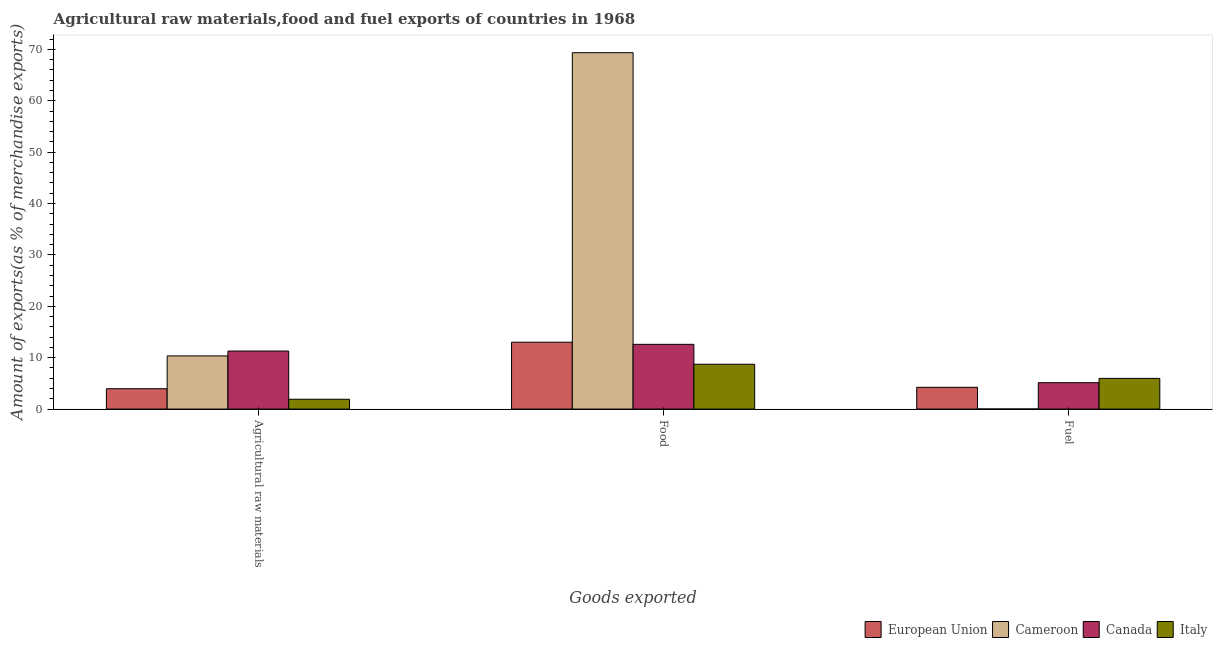How many different coloured bars are there?
Make the answer very short. 4. Are the number of bars per tick equal to the number of legend labels?
Give a very brief answer. Yes. Are the number of bars on each tick of the X-axis equal?
Ensure brevity in your answer.  Yes. How many bars are there on the 2nd tick from the left?
Offer a terse response. 4. How many bars are there on the 1st tick from the right?
Provide a succinct answer. 4. What is the label of the 2nd group of bars from the left?
Ensure brevity in your answer.  Food. What is the percentage of raw materials exports in Canada?
Provide a short and direct response. 11.29. Across all countries, what is the maximum percentage of food exports?
Provide a succinct answer. 69.35. Across all countries, what is the minimum percentage of fuel exports?
Keep it short and to the point. 0.01. In which country was the percentage of fuel exports minimum?
Offer a terse response. Cameroon. What is the total percentage of food exports in the graph?
Your answer should be very brief. 103.68. What is the difference between the percentage of raw materials exports in Canada and that in Cameroon?
Give a very brief answer. 0.95. What is the difference between the percentage of fuel exports in Canada and the percentage of raw materials exports in Italy?
Give a very brief answer. 3.22. What is the average percentage of fuel exports per country?
Your response must be concise. 3.84. What is the difference between the percentage of food exports and percentage of fuel exports in Canada?
Provide a succinct answer. 7.46. What is the ratio of the percentage of fuel exports in Italy to that in European Union?
Give a very brief answer. 1.41. Is the difference between the percentage of food exports in Canada and European Union greater than the difference between the percentage of fuel exports in Canada and European Union?
Keep it short and to the point. No. What is the difference between the highest and the second highest percentage of food exports?
Offer a very short reply. 56.34. What is the difference between the highest and the lowest percentage of fuel exports?
Offer a very short reply. 5.96. Is the sum of the percentage of food exports in Canada and Cameroon greater than the maximum percentage of fuel exports across all countries?
Provide a succinct answer. Yes. What does the 3rd bar from the left in Fuel represents?
Your answer should be very brief. Canada. Are the values on the major ticks of Y-axis written in scientific E-notation?
Provide a short and direct response. No. How many legend labels are there?
Make the answer very short. 4. What is the title of the graph?
Give a very brief answer. Agricultural raw materials,food and fuel exports of countries in 1968. What is the label or title of the X-axis?
Provide a succinct answer. Goods exported. What is the label or title of the Y-axis?
Keep it short and to the point. Amount of exports(as % of merchandise exports). What is the Amount of exports(as % of merchandise exports) in European Union in Agricultural raw materials?
Make the answer very short. 3.96. What is the Amount of exports(as % of merchandise exports) of Cameroon in Agricultural raw materials?
Offer a very short reply. 10.34. What is the Amount of exports(as % of merchandise exports) in Canada in Agricultural raw materials?
Keep it short and to the point. 11.29. What is the Amount of exports(as % of merchandise exports) in Italy in Agricultural raw materials?
Provide a short and direct response. 1.91. What is the Amount of exports(as % of merchandise exports) of European Union in Food?
Your response must be concise. 13.01. What is the Amount of exports(as % of merchandise exports) of Cameroon in Food?
Give a very brief answer. 69.35. What is the Amount of exports(as % of merchandise exports) of Canada in Food?
Make the answer very short. 12.6. What is the Amount of exports(as % of merchandise exports) of Italy in Food?
Keep it short and to the point. 8.72. What is the Amount of exports(as % of merchandise exports) of European Union in Fuel?
Ensure brevity in your answer.  4.24. What is the Amount of exports(as % of merchandise exports) in Cameroon in Fuel?
Ensure brevity in your answer.  0.01. What is the Amount of exports(as % of merchandise exports) in Canada in Fuel?
Ensure brevity in your answer.  5.13. What is the Amount of exports(as % of merchandise exports) of Italy in Fuel?
Provide a short and direct response. 5.97. Across all Goods exported, what is the maximum Amount of exports(as % of merchandise exports) in European Union?
Make the answer very short. 13.01. Across all Goods exported, what is the maximum Amount of exports(as % of merchandise exports) of Cameroon?
Keep it short and to the point. 69.35. Across all Goods exported, what is the maximum Amount of exports(as % of merchandise exports) of Canada?
Ensure brevity in your answer.  12.6. Across all Goods exported, what is the maximum Amount of exports(as % of merchandise exports) of Italy?
Ensure brevity in your answer.  8.72. Across all Goods exported, what is the minimum Amount of exports(as % of merchandise exports) of European Union?
Keep it short and to the point. 3.96. Across all Goods exported, what is the minimum Amount of exports(as % of merchandise exports) in Cameroon?
Offer a terse response. 0.01. Across all Goods exported, what is the minimum Amount of exports(as % of merchandise exports) of Canada?
Offer a very short reply. 5.13. Across all Goods exported, what is the minimum Amount of exports(as % of merchandise exports) in Italy?
Make the answer very short. 1.91. What is the total Amount of exports(as % of merchandise exports) in European Union in the graph?
Give a very brief answer. 21.21. What is the total Amount of exports(as % of merchandise exports) in Cameroon in the graph?
Provide a short and direct response. 79.71. What is the total Amount of exports(as % of merchandise exports) in Canada in the graph?
Offer a terse response. 29.03. What is the total Amount of exports(as % of merchandise exports) in Italy in the graph?
Your answer should be very brief. 16.61. What is the difference between the Amount of exports(as % of merchandise exports) in European Union in Agricultural raw materials and that in Food?
Give a very brief answer. -9.05. What is the difference between the Amount of exports(as % of merchandise exports) of Cameroon in Agricultural raw materials and that in Food?
Offer a terse response. -59.01. What is the difference between the Amount of exports(as % of merchandise exports) of Canada in Agricultural raw materials and that in Food?
Your answer should be compact. -1.31. What is the difference between the Amount of exports(as % of merchandise exports) in Italy in Agricultural raw materials and that in Food?
Keep it short and to the point. -6.81. What is the difference between the Amount of exports(as % of merchandise exports) in European Union in Agricultural raw materials and that in Fuel?
Your response must be concise. -0.28. What is the difference between the Amount of exports(as % of merchandise exports) in Cameroon in Agricultural raw materials and that in Fuel?
Give a very brief answer. 10.33. What is the difference between the Amount of exports(as % of merchandise exports) of Canada in Agricultural raw materials and that in Fuel?
Offer a very short reply. 6.16. What is the difference between the Amount of exports(as % of merchandise exports) of Italy in Agricultural raw materials and that in Fuel?
Offer a very short reply. -4.06. What is the difference between the Amount of exports(as % of merchandise exports) in European Union in Food and that in Fuel?
Keep it short and to the point. 8.77. What is the difference between the Amount of exports(as % of merchandise exports) in Cameroon in Food and that in Fuel?
Your answer should be very brief. 69.34. What is the difference between the Amount of exports(as % of merchandise exports) of Canada in Food and that in Fuel?
Give a very brief answer. 7.46. What is the difference between the Amount of exports(as % of merchandise exports) in Italy in Food and that in Fuel?
Offer a terse response. 2.75. What is the difference between the Amount of exports(as % of merchandise exports) of European Union in Agricultural raw materials and the Amount of exports(as % of merchandise exports) of Cameroon in Food?
Make the answer very short. -65.39. What is the difference between the Amount of exports(as % of merchandise exports) in European Union in Agricultural raw materials and the Amount of exports(as % of merchandise exports) in Canada in Food?
Provide a short and direct response. -8.64. What is the difference between the Amount of exports(as % of merchandise exports) in European Union in Agricultural raw materials and the Amount of exports(as % of merchandise exports) in Italy in Food?
Keep it short and to the point. -4.76. What is the difference between the Amount of exports(as % of merchandise exports) in Cameroon in Agricultural raw materials and the Amount of exports(as % of merchandise exports) in Canada in Food?
Your answer should be compact. -2.25. What is the difference between the Amount of exports(as % of merchandise exports) in Cameroon in Agricultural raw materials and the Amount of exports(as % of merchandise exports) in Italy in Food?
Make the answer very short. 1.62. What is the difference between the Amount of exports(as % of merchandise exports) in Canada in Agricultural raw materials and the Amount of exports(as % of merchandise exports) in Italy in Food?
Offer a very short reply. 2.57. What is the difference between the Amount of exports(as % of merchandise exports) in European Union in Agricultural raw materials and the Amount of exports(as % of merchandise exports) in Cameroon in Fuel?
Offer a very short reply. 3.95. What is the difference between the Amount of exports(as % of merchandise exports) in European Union in Agricultural raw materials and the Amount of exports(as % of merchandise exports) in Canada in Fuel?
Keep it short and to the point. -1.17. What is the difference between the Amount of exports(as % of merchandise exports) in European Union in Agricultural raw materials and the Amount of exports(as % of merchandise exports) in Italy in Fuel?
Your answer should be very brief. -2.01. What is the difference between the Amount of exports(as % of merchandise exports) of Cameroon in Agricultural raw materials and the Amount of exports(as % of merchandise exports) of Canada in Fuel?
Provide a succinct answer. 5.21. What is the difference between the Amount of exports(as % of merchandise exports) of Cameroon in Agricultural raw materials and the Amount of exports(as % of merchandise exports) of Italy in Fuel?
Give a very brief answer. 4.38. What is the difference between the Amount of exports(as % of merchandise exports) in Canada in Agricultural raw materials and the Amount of exports(as % of merchandise exports) in Italy in Fuel?
Provide a short and direct response. 5.32. What is the difference between the Amount of exports(as % of merchandise exports) of European Union in Food and the Amount of exports(as % of merchandise exports) of Cameroon in Fuel?
Provide a short and direct response. 13. What is the difference between the Amount of exports(as % of merchandise exports) in European Union in Food and the Amount of exports(as % of merchandise exports) in Canada in Fuel?
Give a very brief answer. 7.88. What is the difference between the Amount of exports(as % of merchandise exports) of European Union in Food and the Amount of exports(as % of merchandise exports) of Italy in Fuel?
Your answer should be compact. 7.04. What is the difference between the Amount of exports(as % of merchandise exports) in Cameroon in Food and the Amount of exports(as % of merchandise exports) in Canada in Fuel?
Your answer should be compact. 64.22. What is the difference between the Amount of exports(as % of merchandise exports) of Cameroon in Food and the Amount of exports(as % of merchandise exports) of Italy in Fuel?
Make the answer very short. 63.38. What is the difference between the Amount of exports(as % of merchandise exports) in Canada in Food and the Amount of exports(as % of merchandise exports) in Italy in Fuel?
Provide a succinct answer. 6.63. What is the average Amount of exports(as % of merchandise exports) of European Union per Goods exported?
Keep it short and to the point. 7.07. What is the average Amount of exports(as % of merchandise exports) of Cameroon per Goods exported?
Your response must be concise. 26.57. What is the average Amount of exports(as % of merchandise exports) in Canada per Goods exported?
Keep it short and to the point. 9.68. What is the average Amount of exports(as % of merchandise exports) in Italy per Goods exported?
Keep it short and to the point. 5.54. What is the difference between the Amount of exports(as % of merchandise exports) of European Union and Amount of exports(as % of merchandise exports) of Cameroon in Agricultural raw materials?
Offer a terse response. -6.38. What is the difference between the Amount of exports(as % of merchandise exports) of European Union and Amount of exports(as % of merchandise exports) of Canada in Agricultural raw materials?
Keep it short and to the point. -7.33. What is the difference between the Amount of exports(as % of merchandise exports) of European Union and Amount of exports(as % of merchandise exports) of Italy in Agricultural raw materials?
Ensure brevity in your answer.  2.05. What is the difference between the Amount of exports(as % of merchandise exports) in Cameroon and Amount of exports(as % of merchandise exports) in Canada in Agricultural raw materials?
Provide a short and direct response. -0.95. What is the difference between the Amount of exports(as % of merchandise exports) of Cameroon and Amount of exports(as % of merchandise exports) of Italy in Agricultural raw materials?
Your answer should be very brief. 8.43. What is the difference between the Amount of exports(as % of merchandise exports) in Canada and Amount of exports(as % of merchandise exports) in Italy in Agricultural raw materials?
Give a very brief answer. 9.38. What is the difference between the Amount of exports(as % of merchandise exports) in European Union and Amount of exports(as % of merchandise exports) in Cameroon in Food?
Give a very brief answer. -56.34. What is the difference between the Amount of exports(as % of merchandise exports) in European Union and Amount of exports(as % of merchandise exports) in Canada in Food?
Your answer should be compact. 0.41. What is the difference between the Amount of exports(as % of merchandise exports) of European Union and Amount of exports(as % of merchandise exports) of Italy in Food?
Offer a terse response. 4.29. What is the difference between the Amount of exports(as % of merchandise exports) in Cameroon and Amount of exports(as % of merchandise exports) in Canada in Food?
Provide a succinct answer. 56.75. What is the difference between the Amount of exports(as % of merchandise exports) of Cameroon and Amount of exports(as % of merchandise exports) of Italy in Food?
Your answer should be compact. 60.63. What is the difference between the Amount of exports(as % of merchandise exports) in Canada and Amount of exports(as % of merchandise exports) in Italy in Food?
Ensure brevity in your answer.  3.87. What is the difference between the Amount of exports(as % of merchandise exports) in European Union and Amount of exports(as % of merchandise exports) in Cameroon in Fuel?
Provide a succinct answer. 4.22. What is the difference between the Amount of exports(as % of merchandise exports) of European Union and Amount of exports(as % of merchandise exports) of Canada in Fuel?
Keep it short and to the point. -0.9. What is the difference between the Amount of exports(as % of merchandise exports) of European Union and Amount of exports(as % of merchandise exports) of Italy in Fuel?
Provide a short and direct response. -1.73. What is the difference between the Amount of exports(as % of merchandise exports) in Cameroon and Amount of exports(as % of merchandise exports) in Canada in Fuel?
Provide a succinct answer. -5.12. What is the difference between the Amount of exports(as % of merchandise exports) in Cameroon and Amount of exports(as % of merchandise exports) in Italy in Fuel?
Give a very brief answer. -5.96. What is the difference between the Amount of exports(as % of merchandise exports) in Canada and Amount of exports(as % of merchandise exports) in Italy in Fuel?
Ensure brevity in your answer.  -0.83. What is the ratio of the Amount of exports(as % of merchandise exports) of European Union in Agricultural raw materials to that in Food?
Provide a short and direct response. 0.3. What is the ratio of the Amount of exports(as % of merchandise exports) of Cameroon in Agricultural raw materials to that in Food?
Make the answer very short. 0.15. What is the ratio of the Amount of exports(as % of merchandise exports) in Canada in Agricultural raw materials to that in Food?
Provide a succinct answer. 0.9. What is the ratio of the Amount of exports(as % of merchandise exports) of Italy in Agricultural raw materials to that in Food?
Provide a short and direct response. 0.22. What is the ratio of the Amount of exports(as % of merchandise exports) in European Union in Agricultural raw materials to that in Fuel?
Your answer should be compact. 0.93. What is the ratio of the Amount of exports(as % of merchandise exports) in Cameroon in Agricultural raw materials to that in Fuel?
Keep it short and to the point. 786.47. What is the ratio of the Amount of exports(as % of merchandise exports) in Canada in Agricultural raw materials to that in Fuel?
Offer a terse response. 2.2. What is the ratio of the Amount of exports(as % of merchandise exports) in Italy in Agricultural raw materials to that in Fuel?
Offer a very short reply. 0.32. What is the ratio of the Amount of exports(as % of merchandise exports) in European Union in Food to that in Fuel?
Your answer should be very brief. 3.07. What is the ratio of the Amount of exports(as % of merchandise exports) in Cameroon in Food to that in Fuel?
Your answer should be compact. 5272.37. What is the ratio of the Amount of exports(as % of merchandise exports) in Canada in Food to that in Fuel?
Offer a very short reply. 2.45. What is the ratio of the Amount of exports(as % of merchandise exports) in Italy in Food to that in Fuel?
Make the answer very short. 1.46. What is the difference between the highest and the second highest Amount of exports(as % of merchandise exports) of European Union?
Keep it short and to the point. 8.77. What is the difference between the highest and the second highest Amount of exports(as % of merchandise exports) of Cameroon?
Offer a terse response. 59.01. What is the difference between the highest and the second highest Amount of exports(as % of merchandise exports) of Canada?
Ensure brevity in your answer.  1.31. What is the difference between the highest and the second highest Amount of exports(as % of merchandise exports) in Italy?
Your answer should be compact. 2.75. What is the difference between the highest and the lowest Amount of exports(as % of merchandise exports) of European Union?
Ensure brevity in your answer.  9.05. What is the difference between the highest and the lowest Amount of exports(as % of merchandise exports) of Cameroon?
Provide a short and direct response. 69.34. What is the difference between the highest and the lowest Amount of exports(as % of merchandise exports) in Canada?
Provide a succinct answer. 7.46. What is the difference between the highest and the lowest Amount of exports(as % of merchandise exports) in Italy?
Offer a terse response. 6.81. 